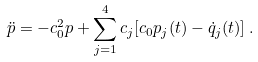Convert formula to latex. <formula><loc_0><loc_0><loc_500><loc_500>\ddot { p } = - c _ { 0 } ^ { 2 } p + \sum _ { j = 1 } ^ { 4 } c _ { j } [ c _ { 0 } p _ { j } ( t ) - \dot { q } _ { j } ( t ) ] \, .</formula> 